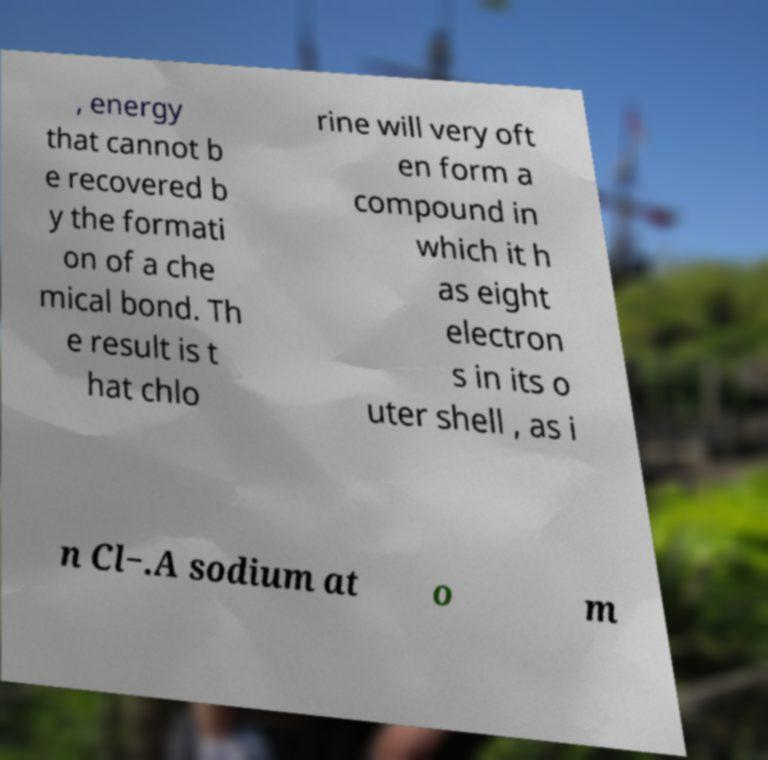Can you accurately transcribe the text from the provided image for me? , energy that cannot b e recovered b y the formati on of a che mical bond. Th e result is t hat chlo rine will very oft en form a compound in which it h as eight electron s in its o uter shell , as i n Cl−.A sodium at o m 